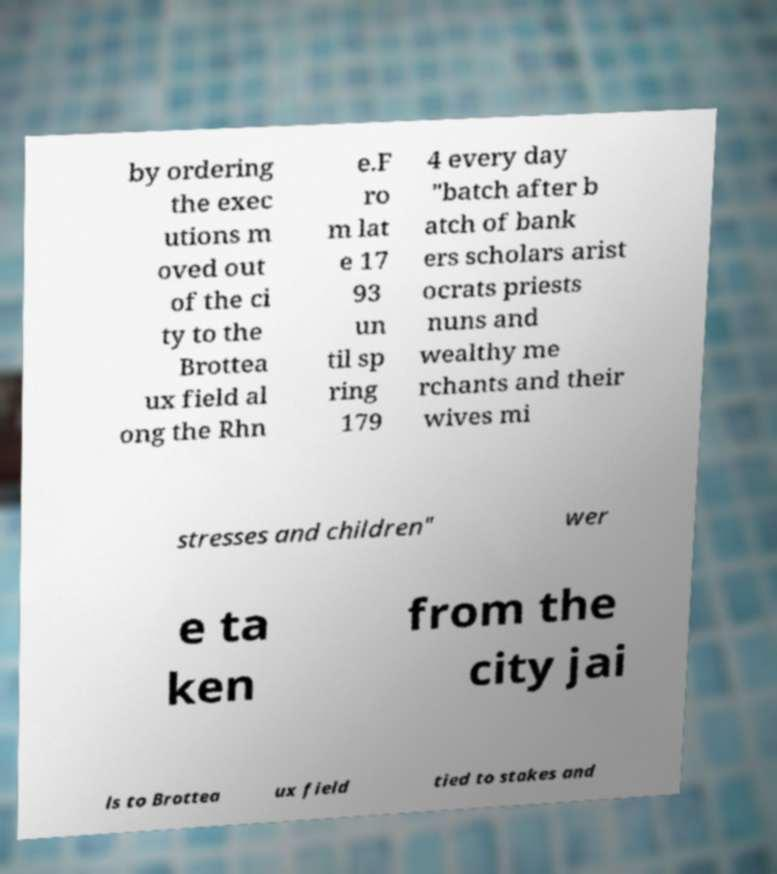There's text embedded in this image that I need extracted. Can you transcribe it verbatim? by ordering the exec utions m oved out of the ci ty to the Brottea ux field al ong the Rhn e.F ro m lat e 17 93 un til sp ring 179 4 every day "batch after b atch of bank ers scholars arist ocrats priests nuns and wealthy me rchants and their wives mi stresses and children" wer e ta ken from the city jai ls to Brottea ux field tied to stakes and 